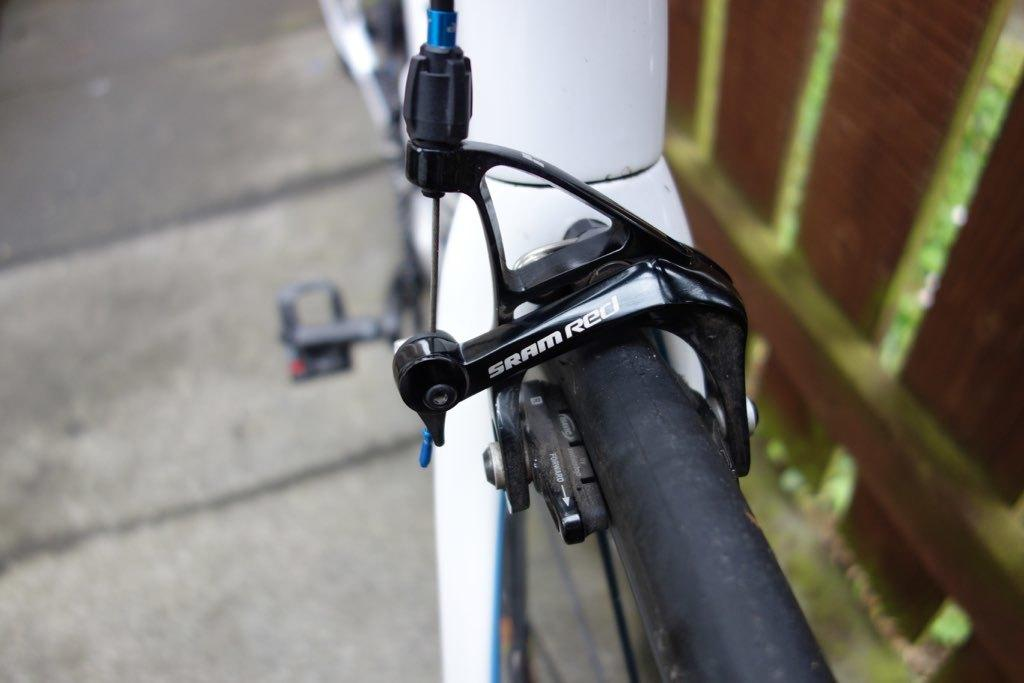What is the main object in the image? There is a bicycle in the image. Is there any text on the bicycle? Yes, there is text written on the bicycle. What can be seen on the right side of the image? There is wooden railing on the right side of the image. What time of day is the operation taking place in the image? There is no operation or indication of time of day in the image; it features a bicycle and wooden railing. What type of earth is visible in the image? There is no earth visible in the image; it features a bicycle and wooden railing. 